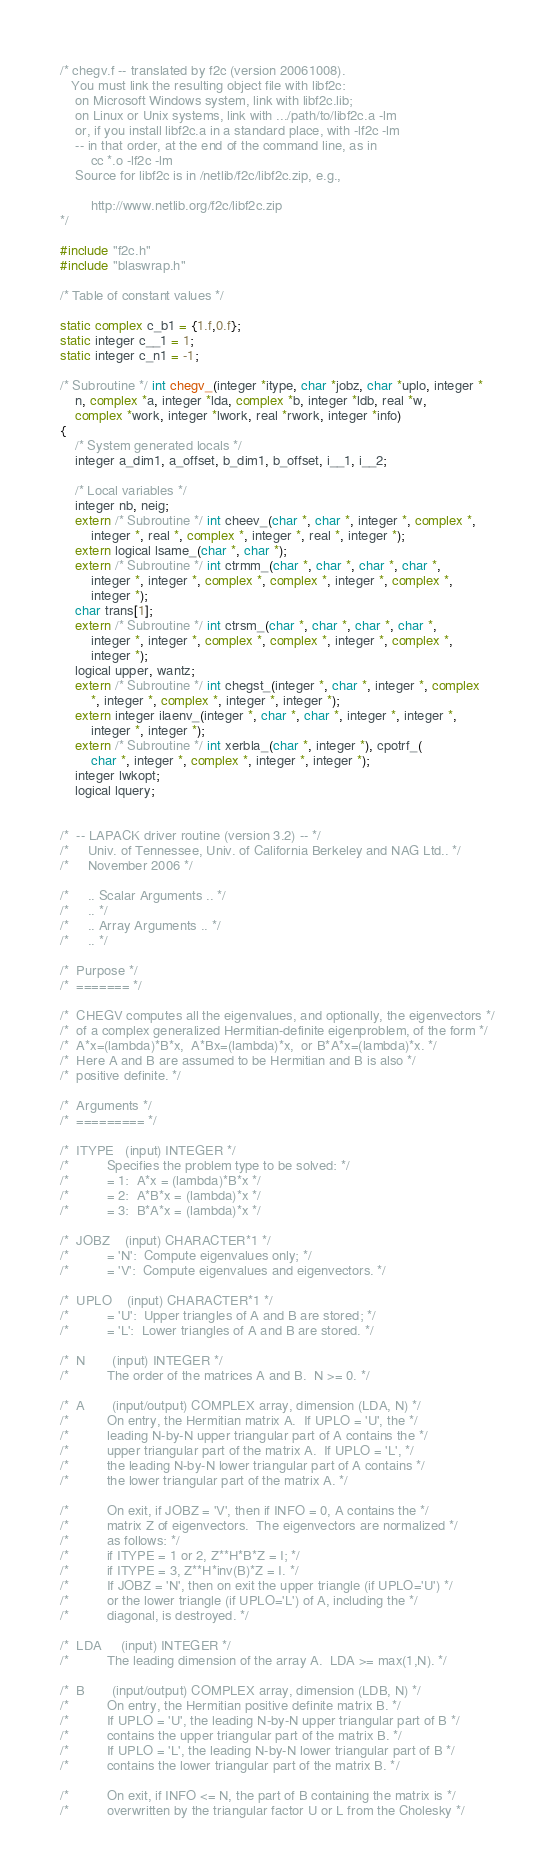Convert code to text. <code><loc_0><loc_0><loc_500><loc_500><_C_>/* chegv.f -- translated by f2c (version 20061008).
   You must link the resulting object file with libf2c:
	on Microsoft Windows system, link with libf2c.lib;
	on Linux or Unix systems, link with .../path/to/libf2c.a -lm
	or, if you install libf2c.a in a standard place, with -lf2c -lm
	-- in that order, at the end of the command line, as in
		cc *.o -lf2c -lm
	Source for libf2c is in /netlib/f2c/libf2c.zip, e.g.,

		http://www.netlib.org/f2c/libf2c.zip
*/

#include "f2c.h"
#include "blaswrap.h"

/* Table of constant values */

static complex c_b1 = {1.f,0.f};
static integer c__1 = 1;
static integer c_n1 = -1;

/* Subroutine */ int chegv_(integer *itype, char *jobz, char *uplo, integer *
	n, complex *a, integer *lda, complex *b, integer *ldb, real *w, 
	complex *work, integer *lwork, real *rwork, integer *info)
{
    /* System generated locals */
    integer a_dim1, a_offset, b_dim1, b_offset, i__1, i__2;

    /* Local variables */
    integer nb, neig;
    extern /* Subroutine */ int cheev_(char *, char *, integer *, complex *, 
	    integer *, real *, complex *, integer *, real *, integer *);
    extern logical lsame_(char *, char *);
    extern /* Subroutine */ int ctrmm_(char *, char *, char *, char *, 
	    integer *, integer *, complex *, complex *, integer *, complex *, 
	    integer *);
    char trans[1];
    extern /* Subroutine */ int ctrsm_(char *, char *, char *, char *, 
	    integer *, integer *, complex *, complex *, integer *, complex *, 
	    integer *);
    logical upper, wantz;
    extern /* Subroutine */ int chegst_(integer *, char *, integer *, complex 
	    *, integer *, complex *, integer *, integer *);
    extern integer ilaenv_(integer *, char *, char *, integer *, integer *, 
	    integer *, integer *);
    extern /* Subroutine */ int xerbla_(char *, integer *), cpotrf_(
	    char *, integer *, complex *, integer *, integer *);
    integer lwkopt;
    logical lquery;


/*  -- LAPACK driver routine (version 3.2) -- */
/*     Univ. of Tennessee, Univ. of California Berkeley and NAG Ltd.. */
/*     November 2006 */

/*     .. Scalar Arguments .. */
/*     .. */
/*     .. Array Arguments .. */
/*     .. */

/*  Purpose */
/*  ======= */

/*  CHEGV computes all the eigenvalues, and optionally, the eigenvectors */
/*  of a complex generalized Hermitian-definite eigenproblem, of the form */
/*  A*x=(lambda)*B*x,  A*Bx=(lambda)*x,  or B*A*x=(lambda)*x. */
/*  Here A and B are assumed to be Hermitian and B is also */
/*  positive definite. */

/*  Arguments */
/*  ========= */

/*  ITYPE   (input) INTEGER */
/*          Specifies the problem type to be solved: */
/*          = 1:  A*x = (lambda)*B*x */
/*          = 2:  A*B*x = (lambda)*x */
/*          = 3:  B*A*x = (lambda)*x */

/*  JOBZ    (input) CHARACTER*1 */
/*          = 'N':  Compute eigenvalues only; */
/*          = 'V':  Compute eigenvalues and eigenvectors. */

/*  UPLO    (input) CHARACTER*1 */
/*          = 'U':  Upper triangles of A and B are stored; */
/*          = 'L':  Lower triangles of A and B are stored. */

/*  N       (input) INTEGER */
/*          The order of the matrices A and B.  N >= 0. */

/*  A       (input/output) COMPLEX array, dimension (LDA, N) */
/*          On entry, the Hermitian matrix A.  If UPLO = 'U', the */
/*          leading N-by-N upper triangular part of A contains the */
/*          upper triangular part of the matrix A.  If UPLO = 'L', */
/*          the leading N-by-N lower triangular part of A contains */
/*          the lower triangular part of the matrix A. */

/*          On exit, if JOBZ = 'V', then if INFO = 0, A contains the */
/*          matrix Z of eigenvectors.  The eigenvectors are normalized */
/*          as follows: */
/*          if ITYPE = 1 or 2, Z**H*B*Z = I; */
/*          if ITYPE = 3, Z**H*inv(B)*Z = I. */
/*          If JOBZ = 'N', then on exit the upper triangle (if UPLO='U') */
/*          or the lower triangle (if UPLO='L') of A, including the */
/*          diagonal, is destroyed. */

/*  LDA     (input) INTEGER */
/*          The leading dimension of the array A.  LDA >= max(1,N). */

/*  B       (input/output) COMPLEX array, dimension (LDB, N) */
/*          On entry, the Hermitian positive definite matrix B. */
/*          If UPLO = 'U', the leading N-by-N upper triangular part of B */
/*          contains the upper triangular part of the matrix B. */
/*          If UPLO = 'L', the leading N-by-N lower triangular part of B */
/*          contains the lower triangular part of the matrix B. */

/*          On exit, if INFO <= N, the part of B containing the matrix is */
/*          overwritten by the triangular factor U or L from the Cholesky */</code> 